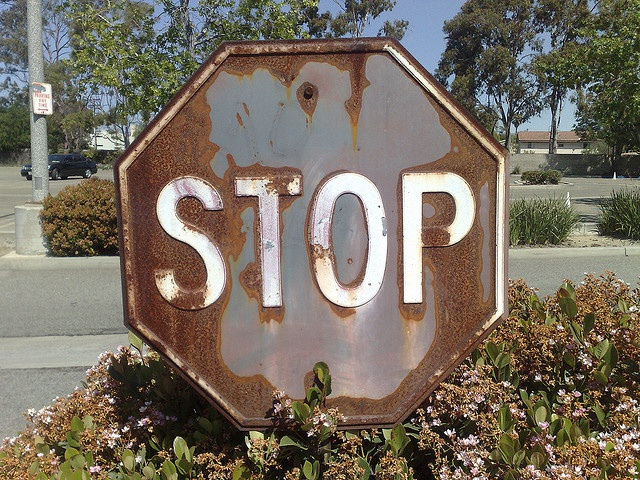Describe the objects in this image and their specific colors. I can see stop sign in gray, brown, and white tones and car in gray, black, and blue tones in this image. 